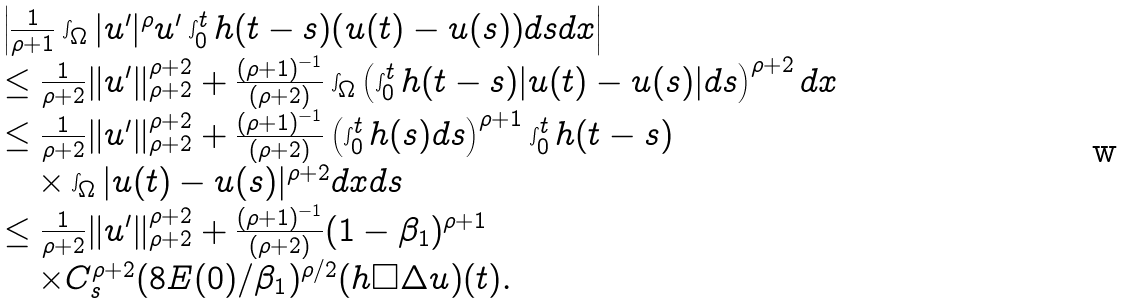Convert formula to latex. <formula><loc_0><loc_0><loc_500><loc_500>\begin{array} { l l } & \left | \frac { 1 } { \rho + 1 } \int _ { \Omega } | u ^ { \prime } | ^ { \rho } u ^ { \prime } \int _ { 0 } ^ { t } h ( t - s ) ( u ( t ) - u ( s ) ) d s d x \right | \\ & \leq \frac { 1 } { \rho + 2 } \| u ^ { \prime } \| ^ { \rho + 2 } _ { \rho + 2 } + \frac { ( \rho + 1 ) ^ { - 1 } } { ( \rho + 2 ) } \int _ { \Omega } \left ( \int _ { 0 } ^ { t } h ( t - s ) | u ( t ) - u ( s ) | d s \right ) ^ { \rho + 2 } d x \\ & \leq \frac { 1 } { \rho + 2 } \| u ^ { \prime } \| ^ { \rho + 2 } _ { \rho + 2 } + \frac { ( \rho + 1 ) ^ { - 1 } } { ( \rho + 2 ) } \left ( \int _ { 0 } ^ { t } h ( s ) d s \right ) ^ { \rho + 1 } \int _ { 0 } ^ { t } h ( t - s ) \\ & \quad \times \int _ { \Omega } | u ( t ) - u ( s ) | ^ { \rho + 2 } d x d s \\ & \leq \frac { 1 } { \rho + 2 } \| u ^ { \prime } \| ^ { \rho + 2 } _ { \rho + 2 } + \frac { ( \rho + 1 ) ^ { - 1 } } { ( \rho + 2 ) } ( 1 - \beta _ { 1 } ) ^ { \rho + 1 } \\ & \quad \times C _ { s } ^ { \rho + 2 } ( 8 E ( 0 ) / \beta _ { 1 } ) ^ { \rho / 2 } ( h \square \Delta u ) ( t ) . \end{array}</formula> 